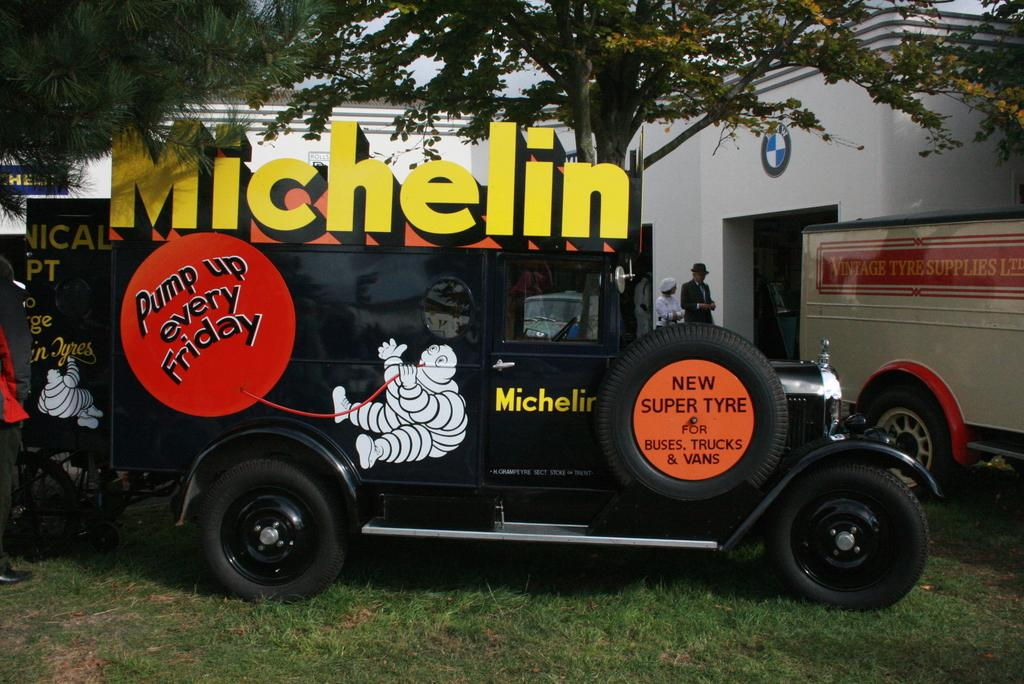What is located on the grass in the image? There are vehicles on the grass in the image. What can be seen in the background of the image? There are people, buildings, and trees in the background of the image. What type of behavior can be observed in the power lines in the image? There are no power lines present in the image, so it is not possible to observe any behavior in them. 